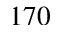<formula> <loc_0><loc_0><loc_500><loc_500>1 7 0</formula> 